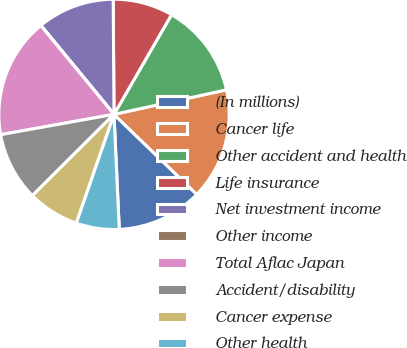<chart> <loc_0><loc_0><loc_500><loc_500><pie_chart><fcel>(In millions)<fcel>Cancer life<fcel>Other accident and health<fcel>Life insurance<fcel>Net investment income<fcel>Other income<fcel>Total Aflac Japan<fcel>Accident/disability<fcel>Cancer expense<fcel>Other health<nl><fcel>12.04%<fcel>15.65%<fcel>13.25%<fcel>8.44%<fcel>10.84%<fcel>0.02%<fcel>16.85%<fcel>9.64%<fcel>7.23%<fcel>6.03%<nl></chart> 